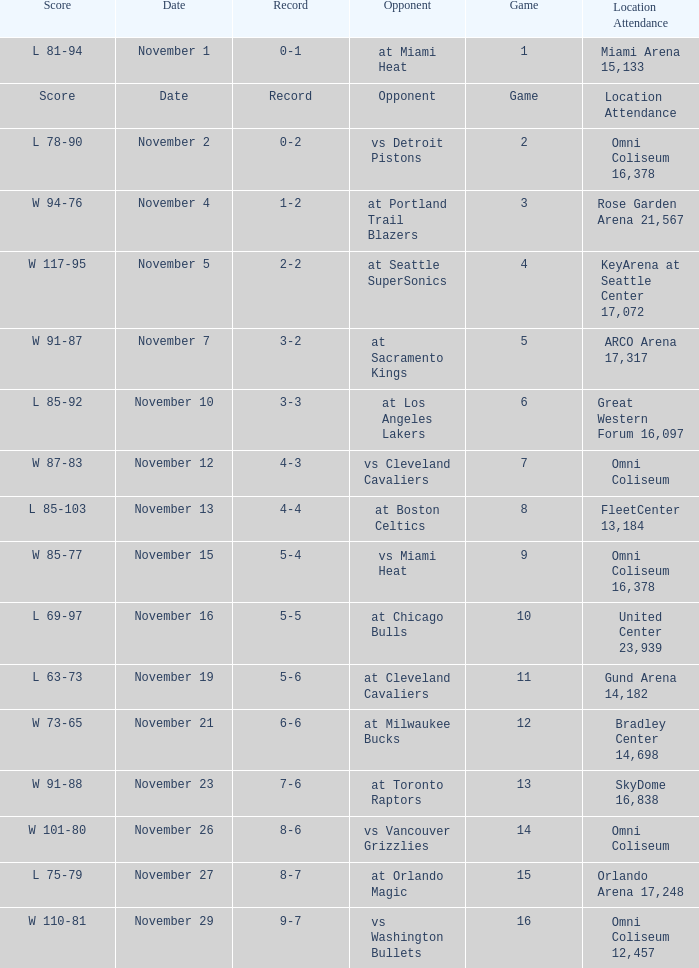Who was their opponent in game 4? At seattle supersonics. 